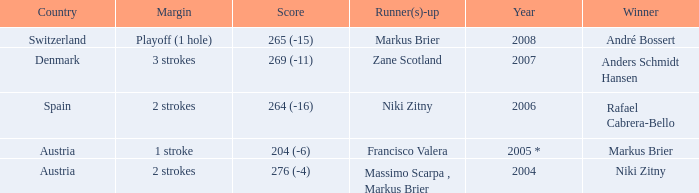Who was the runner-up when the margin was 1 stroke? Francisco Valera. 